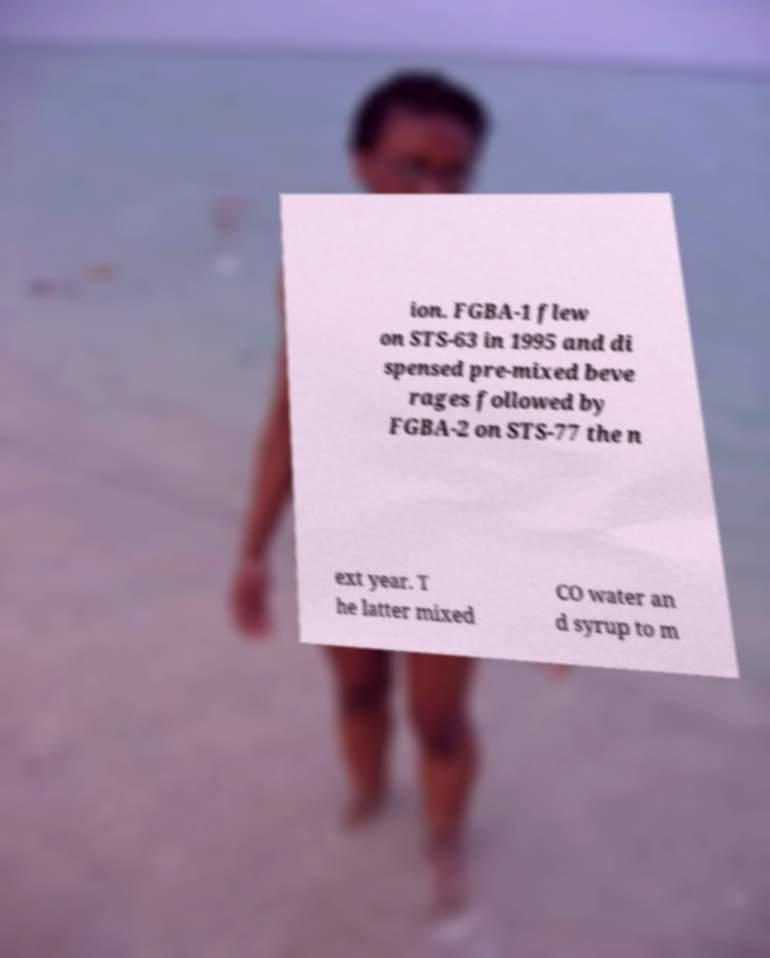For documentation purposes, I need the text within this image transcribed. Could you provide that? ion. FGBA-1 flew on STS-63 in 1995 and di spensed pre-mixed beve rages followed by FGBA-2 on STS-77 the n ext year. T he latter mixed CO water an d syrup to m 